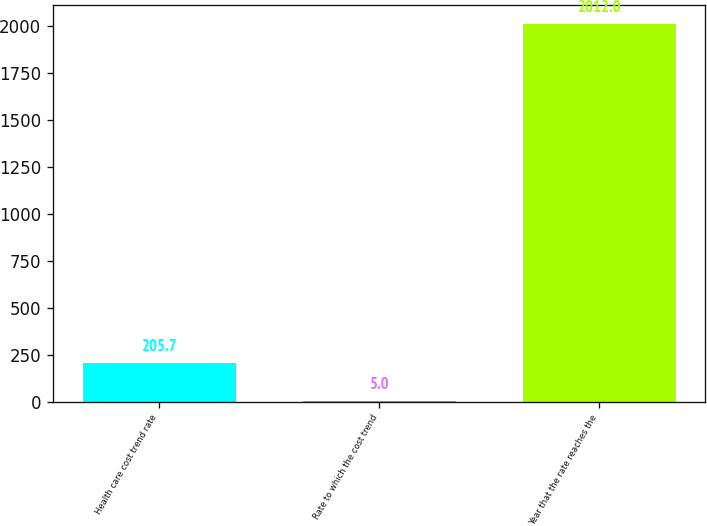Convert chart. <chart><loc_0><loc_0><loc_500><loc_500><bar_chart><fcel>Health care cost trend rate<fcel>Rate to which the cost trend<fcel>Year that the rate reaches the<nl><fcel>205.7<fcel>5<fcel>2012<nl></chart> 